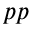Convert formula to latex. <formula><loc_0><loc_0><loc_500><loc_500>p p</formula> 